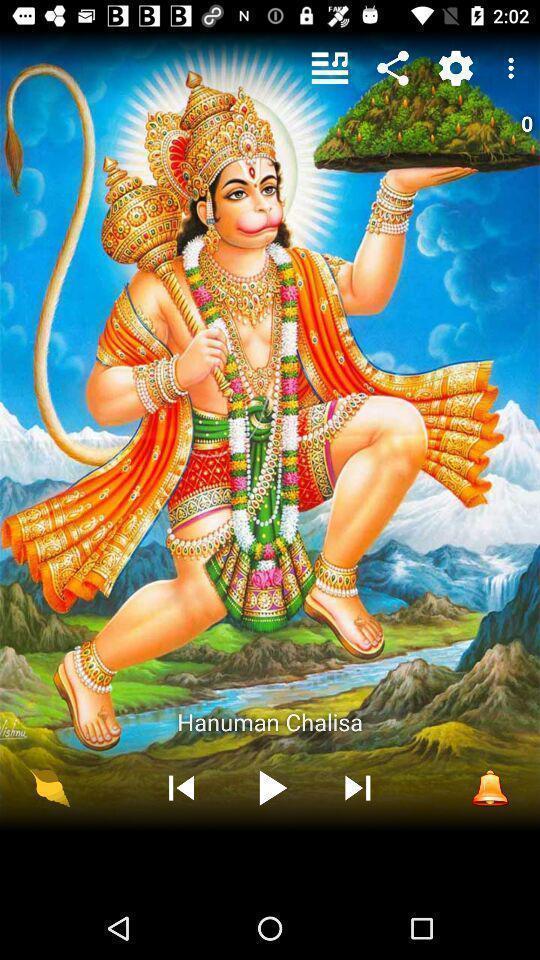Explain what's happening in this screen capture. Screen displaying multiple controls of a song. 